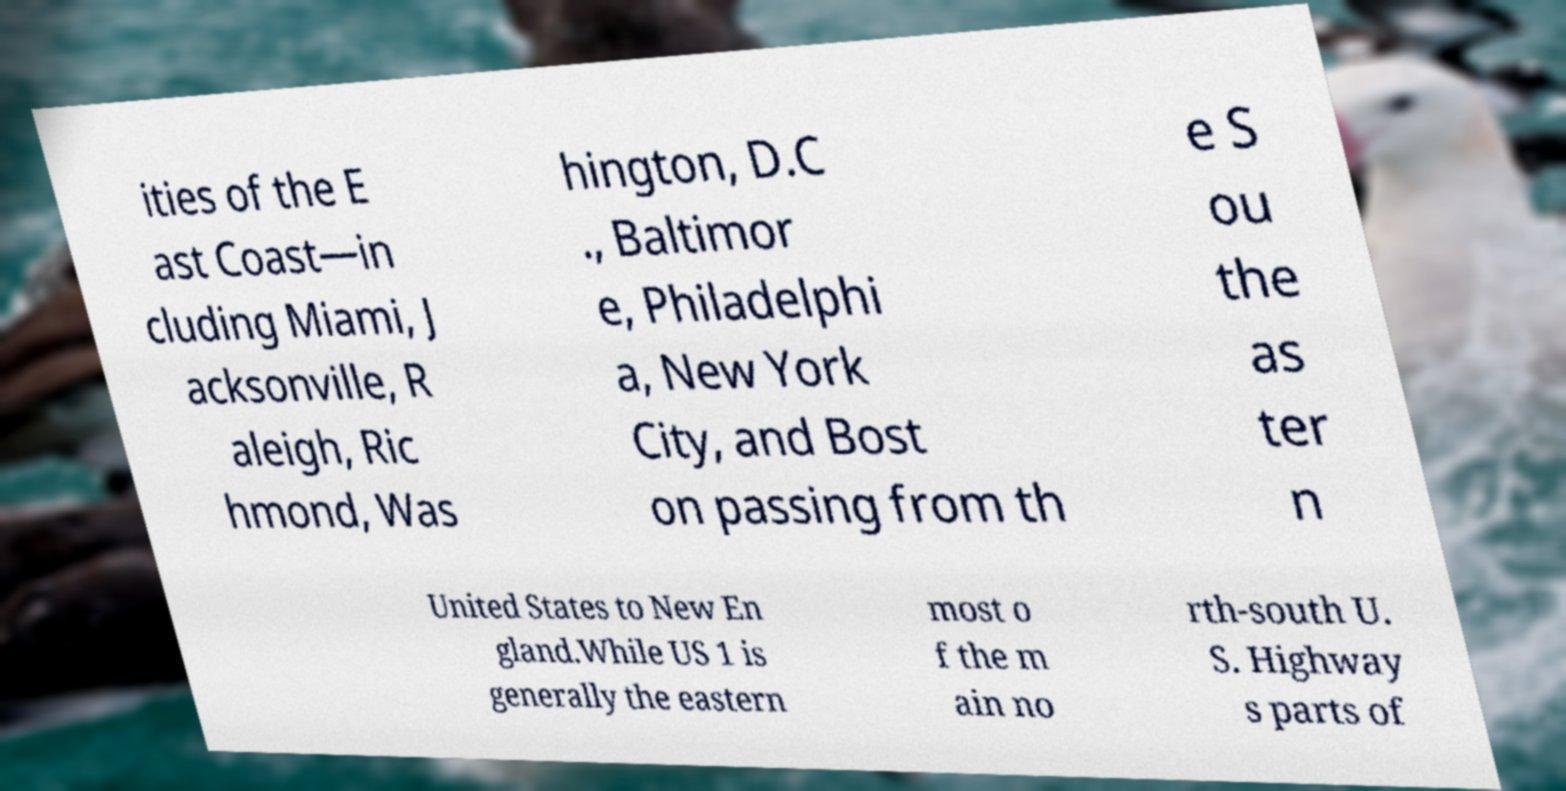Could you extract and type out the text from this image? ities of the E ast Coast—in cluding Miami, J acksonville, R aleigh, Ric hmond, Was hington, D.C ., Baltimor e, Philadelphi a, New York City, and Bost on passing from th e S ou the as ter n United States to New En gland.While US 1 is generally the eastern most o f the m ain no rth-south U. S. Highway s parts of 